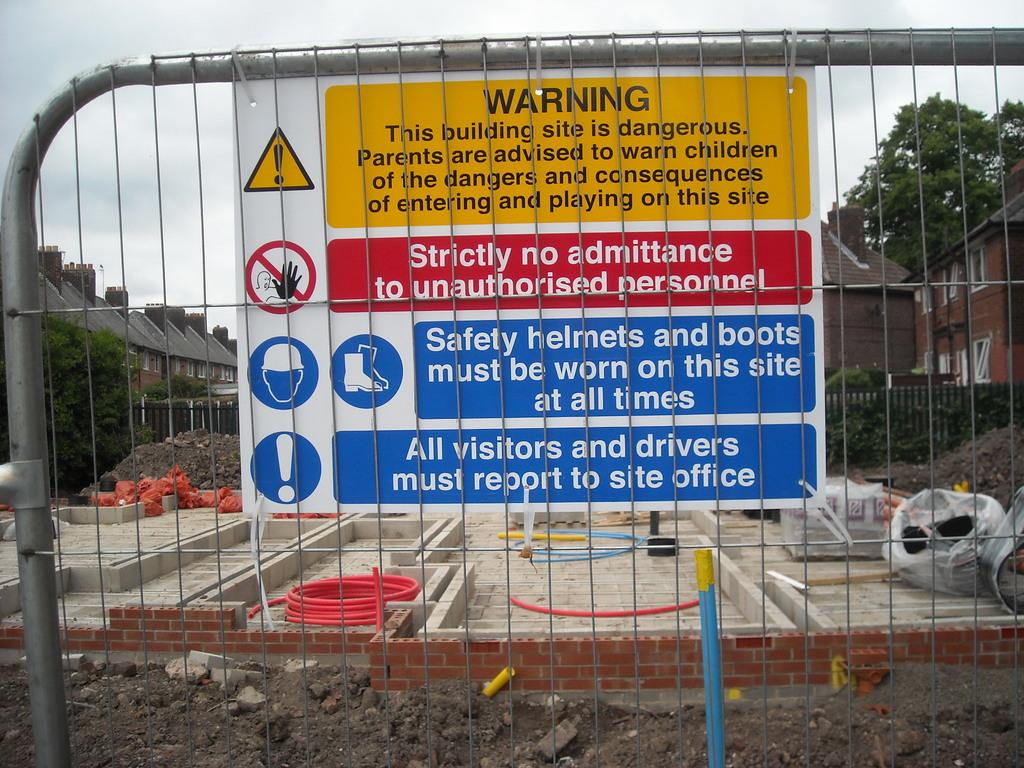Provide a one-sentence caption for the provided image. A warning sign by a construction site includes no unauthorized personnel allowed. 